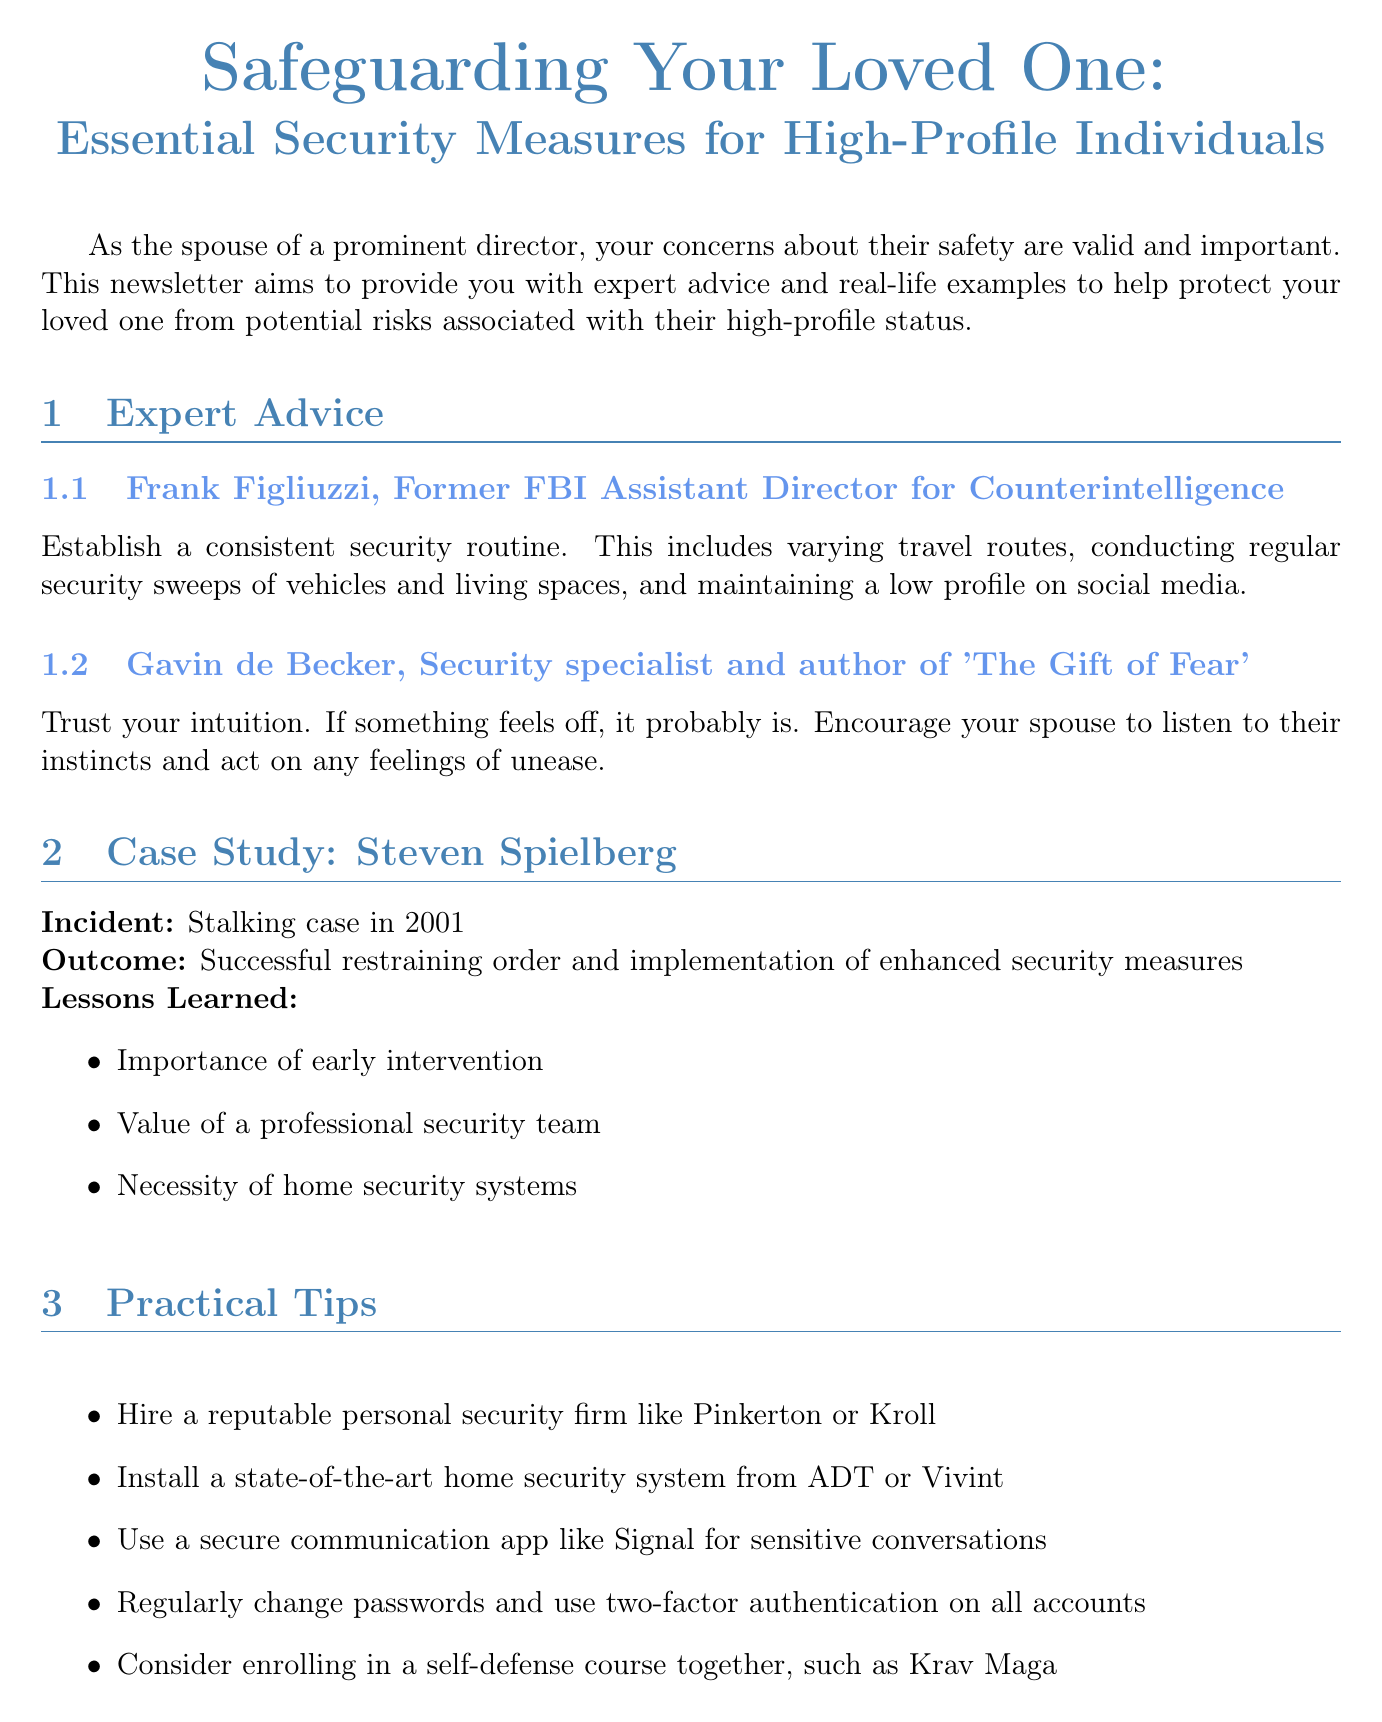What is the title of the newsletter? The title of the newsletter is mentioned at the beginning of the document.
Answer: Safeguarding Your Loved One: Essential Security Measures for High-Profile Individuals Who is the expert that emphasizes establishing a consistent security routine? The expert providing this advice is identified in the expert advice section of the document.
Answer: Frank Figliuzzi What year did the stalking case involving Steven Spielberg occur? The year of the incident is specifically mentioned in the case study section.
Answer: 2001 What is one of the lessons learned from the Steven Spielberg case? The lessons learned are listed in the case study section, highlighting key takeaways.
Answer: Importance of early intervention Name a recommended personal security firm mentioned in the practical tips. The document lists several firms in the practical tips section.
Answer: Pinkerton What communication app is suggested for sensitive conversations? The suggested app is clearly indicated in the practical tips section.
Answer: Signal How many practical tips are provided in the document? The number of tips can be counted from the practical tips section.
Answer: Five What emotional role is highlighted for spouses in relation to safety? The specific emotional role is stated in the emotional support paragraph.
Answer: Providing emotional support 